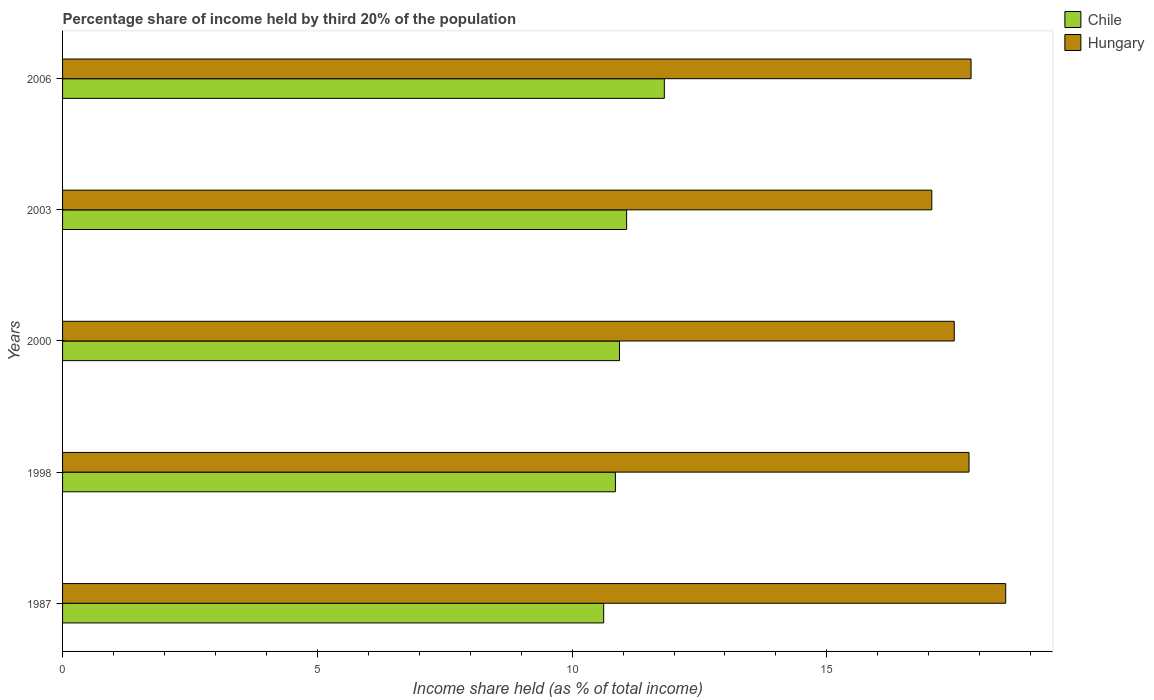Are the number of bars per tick equal to the number of legend labels?
Give a very brief answer. Yes. How many bars are there on the 2nd tick from the top?
Provide a short and direct response. 2. What is the label of the 2nd group of bars from the top?
Your answer should be compact. 2003. What is the share of income held by third 20% of the population in Chile in 2006?
Provide a short and direct response. 11.81. Across all years, what is the maximum share of income held by third 20% of the population in Chile?
Provide a short and direct response. 11.81. Across all years, what is the minimum share of income held by third 20% of the population in Hungary?
Offer a terse response. 17.06. What is the total share of income held by third 20% of the population in Hungary in the graph?
Offer a terse response. 88.69. What is the difference between the share of income held by third 20% of the population in Chile in 1998 and that in 2000?
Make the answer very short. -0.08. What is the difference between the share of income held by third 20% of the population in Chile in 2006 and the share of income held by third 20% of the population in Hungary in 1987?
Give a very brief answer. -6.7. What is the average share of income held by third 20% of the population in Hungary per year?
Provide a succinct answer. 17.74. In the year 2000, what is the difference between the share of income held by third 20% of the population in Hungary and share of income held by third 20% of the population in Chile?
Offer a very short reply. 6.57. In how many years, is the share of income held by third 20% of the population in Hungary greater than 1 %?
Ensure brevity in your answer.  5. What is the ratio of the share of income held by third 20% of the population in Chile in 1998 to that in 2000?
Keep it short and to the point. 0.99. Is the share of income held by third 20% of the population in Chile in 1998 less than that in 2003?
Ensure brevity in your answer.  Yes. Is the difference between the share of income held by third 20% of the population in Hungary in 1998 and 2000 greater than the difference between the share of income held by third 20% of the population in Chile in 1998 and 2000?
Keep it short and to the point. Yes. What is the difference between the highest and the second highest share of income held by third 20% of the population in Hungary?
Give a very brief answer. 0.68. What is the difference between the highest and the lowest share of income held by third 20% of the population in Chile?
Provide a short and direct response. 1.19. Is the sum of the share of income held by third 20% of the population in Chile in 1998 and 2006 greater than the maximum share of income held by third 20% of the population in Hungary across all years?
Give a very brief answer. Yes. What does the 1st bar from the top in 1998 represents?
Make the answer very short. Hungary. What does the 2nd bar from the bottom in 2000 represents?
Ensure brevity in your answer.  Hungary. Are all the bars in the graph horizontal?
Give a very brief answer. Yes. Does the graph contain any zero values?
Make the answer very short. No. Where does the legend appear in the graph?
Offer a terse response. Top right. How many legend labels are there?
Provide a succinct answer. 2. What is the title of the graph?
Make the answer very short. Percentage share of income held by third 20% of the population. What is the label or title of the X-axis?
Your answer should be very brief. Income share held (as % of total income). What is the label or title of the Y-axis?
Offer a terse response. Years. What is the Income share held (as % of total income) of Chile in 1987?
Offer a terse response. 10.62. What is the Income share held (as % of total income) of Hungary in 1987?
Make the answer very short. 18.51. What is the Income share held (as % of total income) in Chile in 1998?
Offer a terse response. 10.85. What is the Income share held (as % of total income) in Hungary in 1998?
Make the answer very short. 17.79. What is the Income share held (as % of total income) of Chile in 2000?
Offer a very short reply. 10.93. What is the Income share held (as % of total income) of Chile in 2003?
Your answer should be compact. 11.07. What is the Income share held (as % of total income) of Hungary in 2003?
Your answer should be compact. 17.06. What is the Income share held (as % of total income) of Chile in 2006?
Provide a succinct answer. 11.81. What is the Income share held (as % of total income) of Hungary in 2006?
Your response must be concise. 17.83. Across all years, what is the maximum Income share held (as % of total income) in Chile?
Provide a succinct answer. 11.81. Across all years, what is the maximum Income share held (as % of total income) in Hungary?
Make the answer very short. 18.51. Across all years, what is the minimum Income share held (as % of total income) of Chile?
Ensure brevity in your answer.  10.62. Across all years, what is the minimum Income share held (as % of total income) in Hungary?
Ensure brevity in your answer.  17.06. What is the total Income share held (as % of total income) in Chile in the graph?
Offer a terse response. 55.28. What is the total Income share held (as % of total income) in Hungary in the graph?
Keep it short and to the point. 88.69. What is the difference between the Income share held (as % of total income) of Chile in 1987 and that in 1998?
Make the answer very short. -0.23. What is the difference between the Income share held (as % of total income) of Hungary in 1987 and that in 1998?
Provide a succinct answer. 0.72. What is the difference between the Income share held (as % of total income) in Chile in 1987 and that in 2000?
Provide a succinct answer. -0.31. What is the difference between the Income share held (as % of total income) in Chile in 1987 and that in 2003?
Offer a very short reply. -0.45. What is the difference between the Income share held (as % of total income) of Hungary in 1987 and that in 2003?
Make the answer very short. 1.45. What is the difference between the Income share held (as % of total income) of Chile in 1987 and that in 2006?
Provide a short and direct response. -1.19. What is the difference between the Income share held (as % of total income) of Hungary in 1987 and that in 2006?
Offer a terse response. 0.68. What is the difference between the Income share held (as % of total income) of Chile in 1998 and that in 2000?
Provide a short and direct response. -0.08. What is the difference between the Income share held (as % of total income) of Hungary in 1998 and that in 2000?
Keep it short and to the point. 0.29. What is the difference between the Income share held (as % of total income) in Chile in 1998 and that in 2003?
Give a very brief answer. -0.22. What is the difference between the Income share held (as % of total income) in Hungary in 1998 and that in 2003?
Your response must be concise. 0.73. What is the difference between the Income share held (as % of total income) in Chile in 1998 and that in 2006?
Your answer should be compact. -0.96. What is the difference between the Income share held (as % of total income) of Hungary in 1998 and that in 2006?
Offer a very short reply. -0.04. What is the difference between the Income share held (as % of total income) of Chile in 2000 and that in 2003?
Offer a very short reply. -0.14. What is the difference between the Income share held (as % of total income) of Hungary in 2000 and that in 2003?
Provide a short and direct response. 0.44. What is the difference between the Income share held (as % of total income) of Chile in 2000 and that in 2006?
Offer a very short reply. -0.88. What is the difference between the Income share held (as % of total income) in Hungary in 2000 and that in 2006?
Ensure brevity in your answer.  -0.33. What is the difference between the Income share held (as % of total income) of Chile in 2003 and that in 2006?
Make the answer very short. -0.74. What is the difference between the Income share held (as % of total income) in Hungary in 2003 and that in 2006?
Your answer should be very brief. -0.77. What is the difference between the Income share held (as % of total income) in Chile in 1987 and the Income share held (as % of total income) in Hungary in 1998?
Your response must be concise. -7.17. What is the difference between the Income share held (as % of total income) in Chile in 1987 and the Income share held (as % of total income) in Hungary in 2000?
Provide a succinct answer. -6.88. What is the difference between the Income share held (as % of total income) of Chile in 1987 and the Income share held (as % of total income) of Hungary in 2003?
Provide a short and direct response. -6.44. What is the difference between the Income share held (as % of total income) of Chile in 1987 and the Income share held (as % of total income) of Hungary in 2006?
Keep it short and to the point. -7.21. What is the difference between the Income share held (as % of total income) in Chile in 1998 and the Income share held (as % of total income) in Hungary in 2000?
Make the answer very short. -6.65. What is the difference between the Income share held (as % of total income) in Chile in 1998 and the Income share held (as % of total income) in Hungary in 2003?
Provide a succinct answer. -6.21. What is the difference between the Income share held (as % of total income) of Chile in 1998 and the Income share held (as % of total income) of Hungary in 2006?
Offer a terse response. -6.98. What is the difference between the Income share held (as % of total income) in Chile in 2000 and the Income share held (as % of total income) in Hungary in 2003?
Your answer should be very brief. -6.13. What is the difference between the Income share held (as % of total income) of Chile in 2003 and the Income share held (as % of total income) of Hungary in 2006?
Your answer should be compact. -6.76. What is the average Income share held (as % of total income) of Chile per year?
Your answer should be compact. 11.06. What is the average Income share held (as % of total income) in Hungary per year?
Provide a succinct answer. 17.74. In the year 1987, what is the difference between the Income share held (as % of total income) of Chile and Income share held (as % of total income) of Hungary?
Provide a short and direct response. -7.89. In the year 1998, what is the difference between the Income share held (as % of total income) of Chile and Income share held (as % of total income) of Hungary?
Give a very brief answer. -6.94. In the year 2000, what is the difference between the Income share held (as % of total income) of Chile and Income share held (as % of total income) of Hungary?
Provide a short and direct response. -6.57. In the year 2003, what is the difference between the Income share held (as % of total income) of Chile and Income share held (as % of total income) of Hungary?
Make the answer very short. -5.99. In the year 2006, what is the difference between the Income share held (as % of total income) in Chile and Income share held (as % of total income) in Hungary?
Offer a terse response. -6.02. What is the ratio of the Income share held (as % of total income) in Chile in 1987 to that in 1998?
Your response must be concise. 0.98. What is the ratio of the Income share held (as % of total income) in Hungary in 1987 to that in 1998?
Provide a short and direct response. 1.04. What is the ratio of the Income share held (as % of total income) of Chile in 1987 to that in 2000?
Offer a terse response. 0.97. What is the ratio of the Income share held (as % of total income) in Hungary in 1987 to that in 2000?
Give a very brief answer. 1.06. What is the ratio of the Income share held (as % of total income) of Chile in 1987 to that in 2003?
Give a very brief answer. 0.96. What is the ratio of the Income share held (as % of total income) of Hungary in 1987 to that in 2003?
Your response must be concise. 1.08. What is the ratio of the Income share held (as % of total income) in Chile in 1987 to that in 2006?
Offer a very short reply. 0.9. What is the ratio of the Income share held (as % of total income) in Hungary in 1987 to that in 2006?
Your response must be concise. 1.04. What is the ratio of the Income share held (as % of total income) of Hungary in 1998 to that in 2000?
Offer a terse response. 1.02. What is the ratio of the Income share held (as % of total income) of Chile in 1998 to that in 2003?
Your answer should be very brief. 0.98. What is the ratio of the Income share held (as % of total income) in Hungary in 1998 to that in 2003?
Your answer should be very brief. 1.04. What is the ratio of the Income share held (as % of total income) of Chile in 1998 to that in 2006?
Offer a very short reply. 0.92. What is the ratio of the Income share held (as % of total income) in Hungary in 1998 to that in 2006?
Provide a short and direct response. 1. What is the ratio of the Income share held (as % of total income) of Chile in 2000 to that in 2003?
Offer a very short reply. 0.99. What is the ratio of the Income share held (as % of total income) in Hungary in 2000 to that in 2003?
Your answer should be compact. 1.03. What is the ratio of the Income share held (as % of total income) of Chile in 2000 to that in 2006?
Keep it short and to the point. 0.93. What is the ratio of the Income share held (as % of total income) in Hungary in 2000 to that in 2006?
Provide a short and direct response. 0.98. What is the ratio of the Income share held (as % of total income) of Chile in 2003 to that in 2006?
Keep it short and to the point. 0.94. What is the ratio of the Income share held (as % of total income) in Hungary in 2003 to that in 2006?
Make the answer very short. 0.96. What is the difference between the highest and the second highest Income share held (as % of total income) of Chile?
Ensure brevity in your answer.  0.74. What is the difference between the highest and the second highest Income share held (as % of total income) of Hungary?
Make the answer very short. 0.68. What is the difference between the highest and the lowest Income share held (as % of total income) of Chile?
Provide a succinct answer. 1.19. What is the difference between the highest and the lowest Income share held (as % of total income) of Hungary?
Keep it short and to the point. 1.45. 